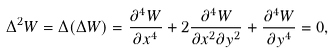Convert formula to latex. <formula><loc_0><loc_0><loc_500><loc_500>\Delta ^ { 2 } W = \Delta ( \Delta W ) = \frac { \partial ^ { 4 } W } { \partial x ^ { 4 } } + 2 \frac { \partial ^ { 4 } W } { \partial x ^ { 2 } \partial y ^ { 2 } } + \frac { \partial ^ { 4 } W } { \partial y ^ { 4 } } = 0 ,</formula> 